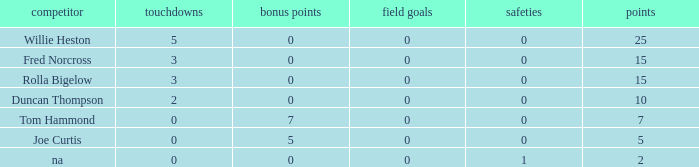How many Touchdowns have a Player of rolla bigelow, and an Extra points smaller than 0? None. 